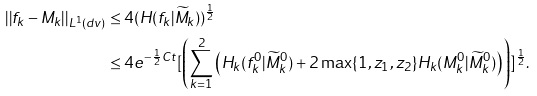<formula> <loc_0><loc_0><loc_500><loc_500>| | f _ { k } - M _ { k } | | _ { L ^ { 1 } ( d v ) } & \leq 4 ( H ( f _ { k } | \widetilde { M } _ { k } ) ) ^ { \frac { 1 } { 2 } } \\ & \leq 4 e ^ { - \frac { 1 } { 2 } C t } [ \left ( \sum _ { k = 1 } ^ { 2 } \left ( H _ { k } ( f _ { k } ^ { 0 } | \widetilde { M } _ { k } ^ { 0 } ) + 2 \max \{ 1 , z _ { 1 } , z _ { 2 } \} H _ { k } ( M _ { k } ^ { 0 } | \widetilde { M } _ { k } ^ { 0 } ) \right ) \right ) ] ^ { \frac { 1 } { 2 } } .</formula> 